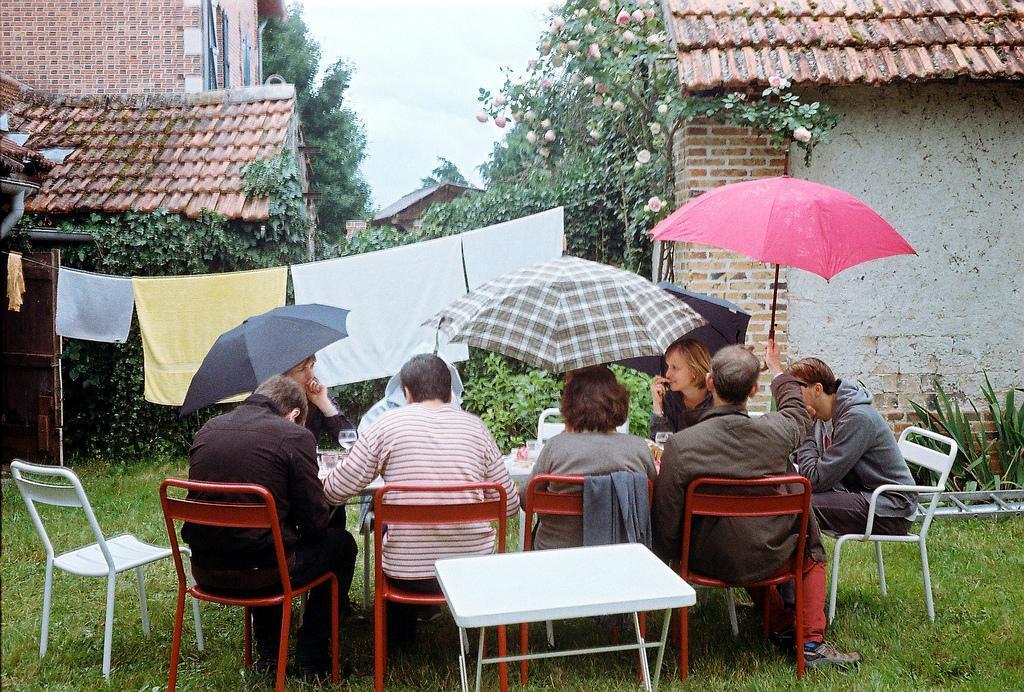How many white towels are in this picture?
Give a very brief answer. 3. 